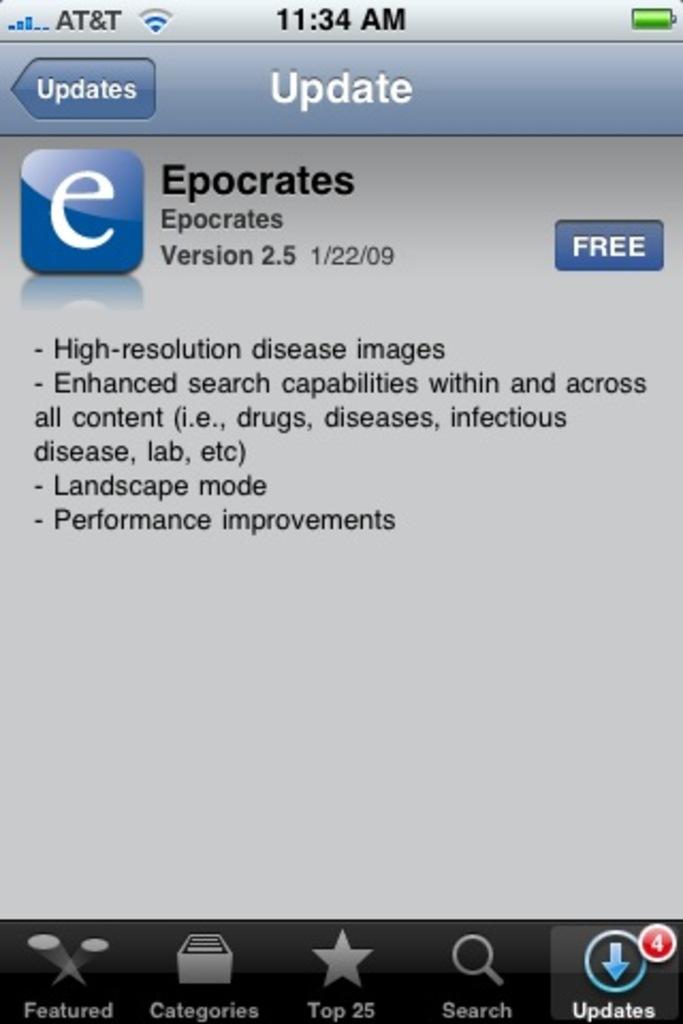What is the name of this app?
Offer a terse response. Epocrates. 